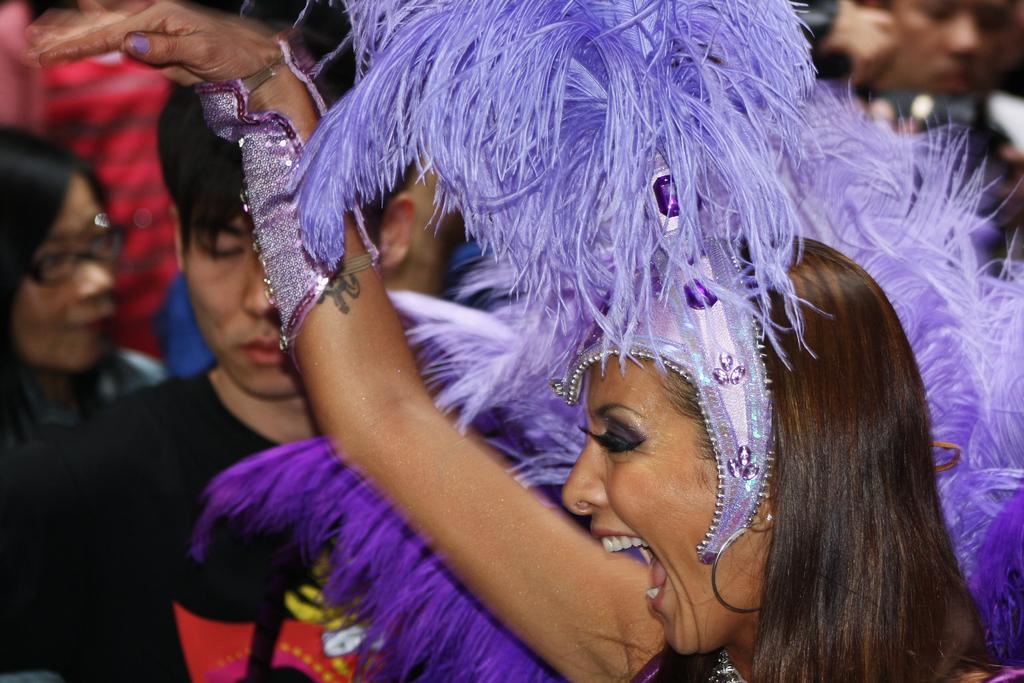Could you give a brief overview of what you see in this image? On the right side, there is a woman doing a performance. In the background, there are other persons. 